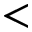Convert formula to latex. <formula><loc_0><loc_0><loc_500><loc_500><</formula> 